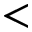Convert formula to latex. <formula><loc_0><loc_0><loc_500><loc_500><</formula> 